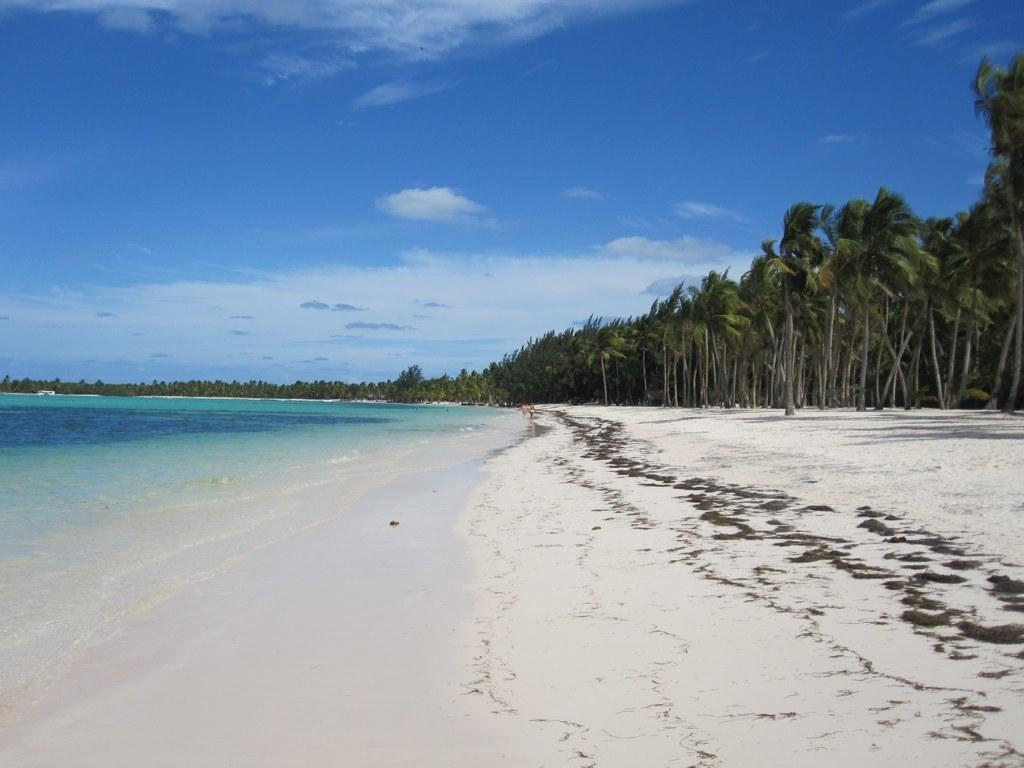Describe this image in one or two sentences. In this image we can see a sea shore, some trees, and the clouded sky. 